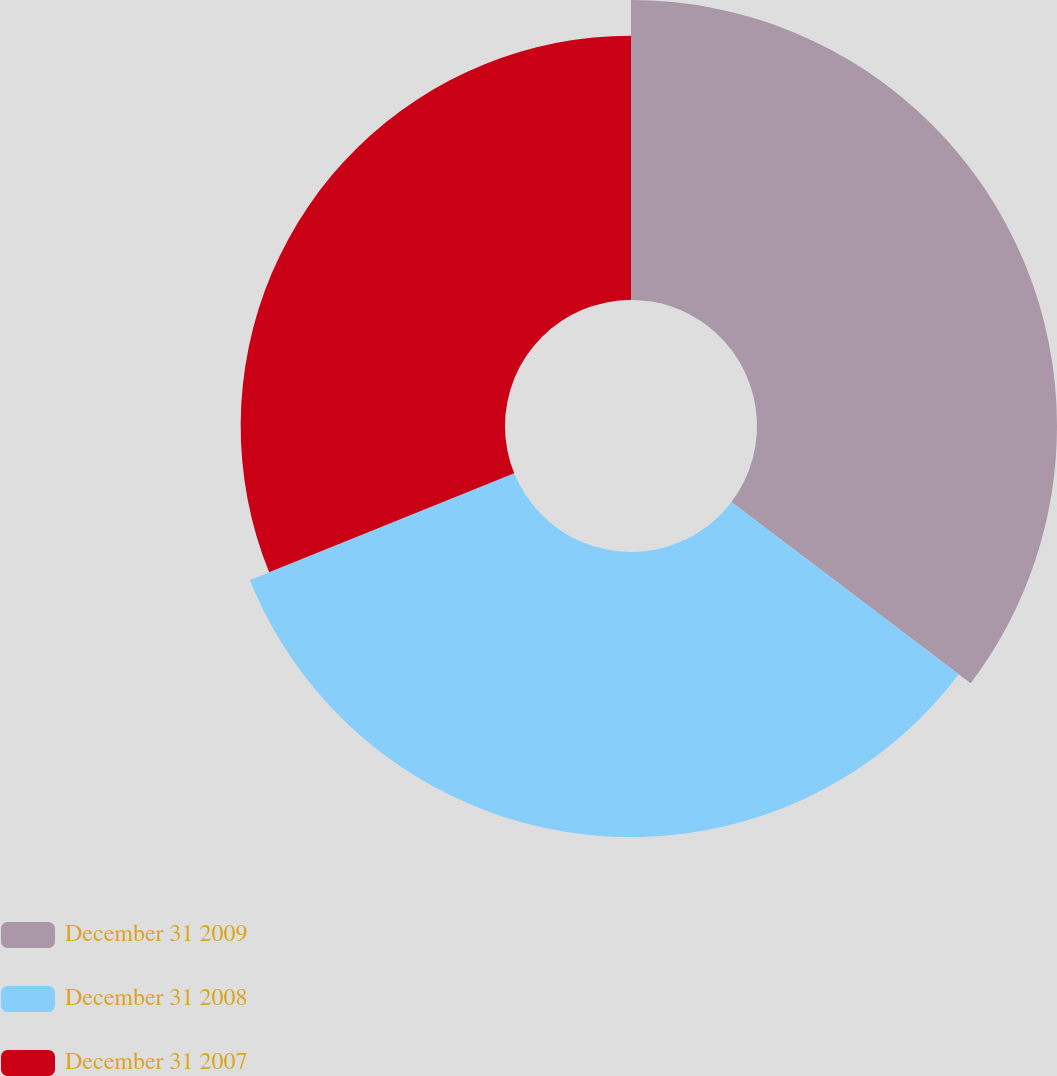Convert chart to OTSL. <chart><loc_0><loc_0><loc_500><loc_500><pie_chart><fcel>December 31 2009<fcel>December 31 2008<fcel>December 31 2007<nl><fcel>35.32%<fcel>33.57%<fcel>31.12%<nl></chart> 